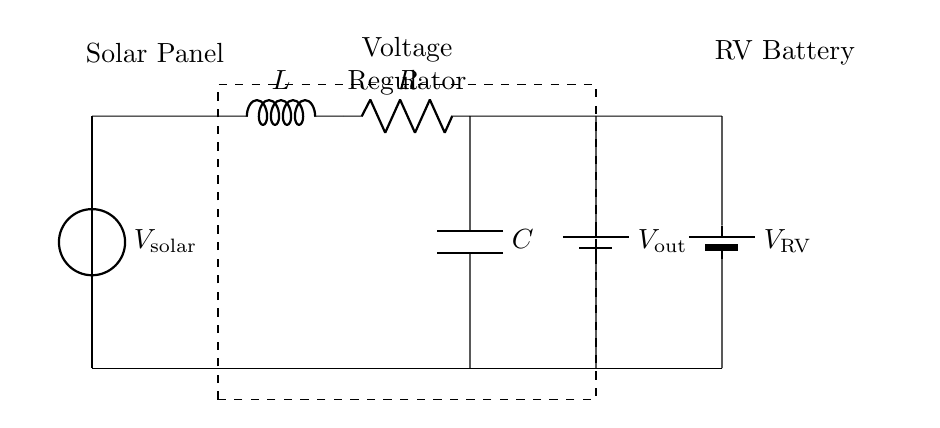What is the voltage of the solar panel? The voltage of the solar panel is represented as V_solar in the circuit diagram. It is indicated at the source and is the input voltage for the circuit.
Answer: V_solar What are the RLC components in this circuit? The RLC components are the resistor, inductor, and capacitor connected sequentially. The circuit shows an inductor (L), a resistor (R), and a capacitor (C) in series as part of the voltage regulator section.
Answer: L, R, C What does the dashed rectangle represent? The dashed rectangle represents the voltage regulator block, which encompasses the RLC circuit components. It indicates that these components work together to regulate the voltage output to the RV battery.
Answer: Voltage Regulator What is the output voltage after the regulator? The output voltage is denoted as V_out, and it is the voltage delivered to the RV battery after the regulation process by the RLC components in the circuit.
Answer: V_out How is the RV battery connected to the circuit? The RV battery is connected in parallel with the output of the voltage regulator circuit, which allows it to receive the regulated voltage (V_out) and charge effectively.
Answer: Parallel connection What is the role of the capacitor in this RLC circuit? The capacitor in the RLC circuit plays a crucial role in filtering and stabilizing the output voltage. It works to smooth out fluctuations in voltage, ensuring steady power delivery to the RV battery.
Answer: Smoothing voltage 